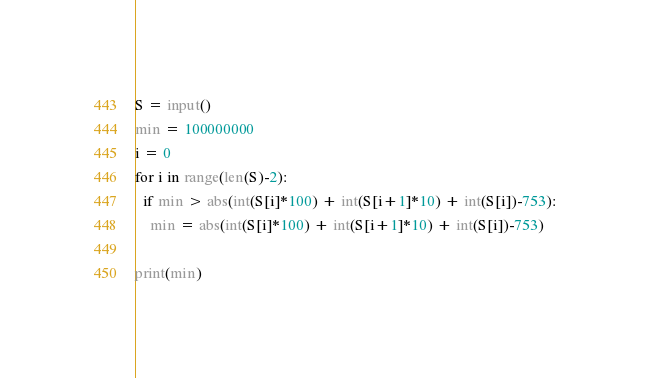<code> <loc_0><loc_0><loc_500><loc_500><_Python_>S = input()
min = 100000000
i = 0
for i in range(len(S)-2):
  if min > abs(int(S[i]*100) + int(S[i+1]*10) + int(S[i])-753):
    min = abs(int(S[i]*100) + int(S[i+1]*10) + int(S[i])-753)
    
print(min)</code> 